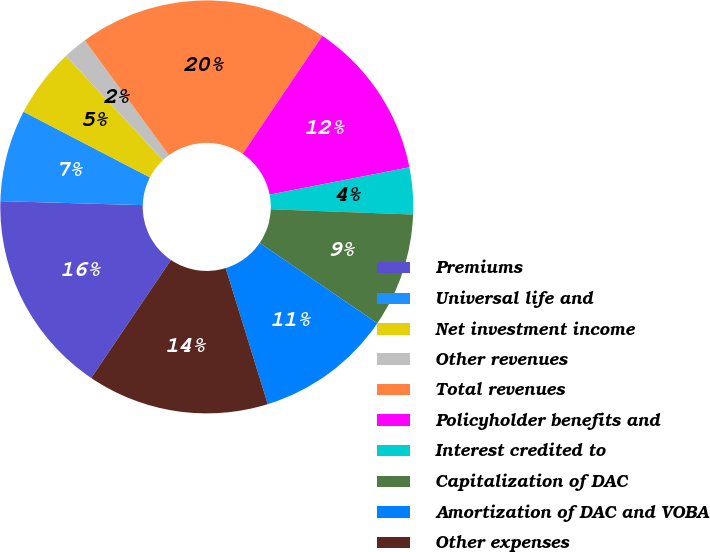Convert chart. <chart><loc_0><loc_0><loc_500><loc_500><pie_chart><fcel>Premiums<fcel>Universal life and<fcel>Net investment income<fcel>Other revenues<fcel>Total revenues<fcel>Policyholder benefits and<fcel>Interest credited to<fcel>Capitalization of DAC<fcel>Amortization of DAC and VOBA<fcel>Other expenses<nl><fcel>15.99%<fcel>7.18%<fcel>5.42%<fcel>1.89%<fcel>19.52%<fcel>12.47%<fcel>3.66%<fcel>8.94%<fcel>10.7%<fcel>14.23%<nl></chart> 